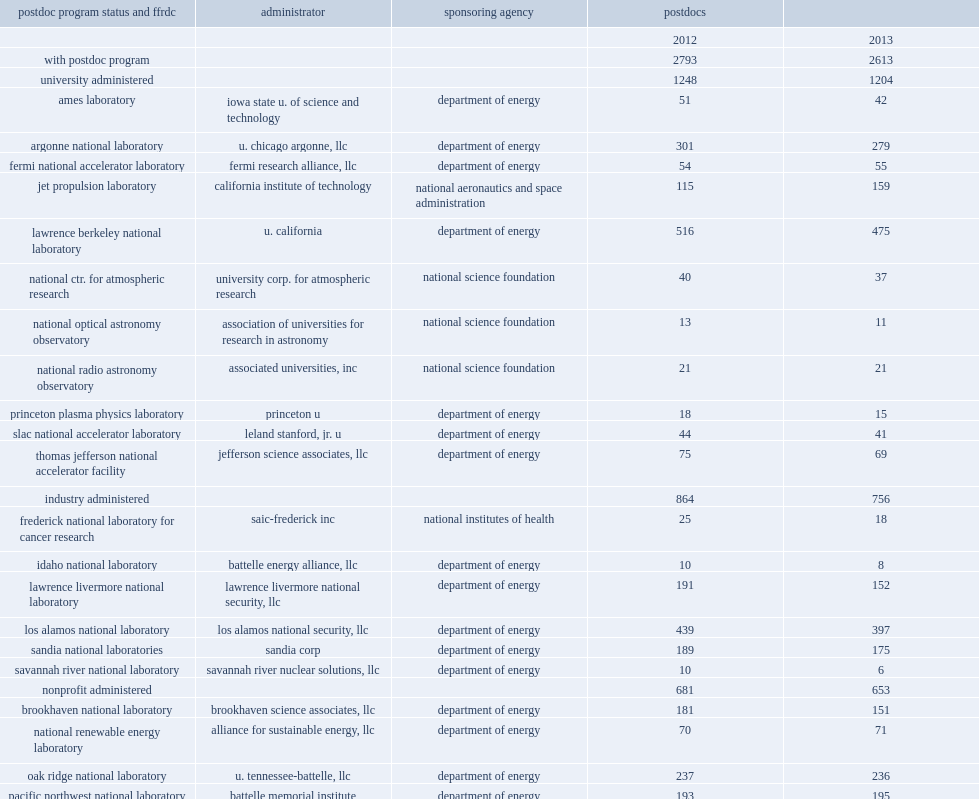How many postdocs did ffrdcs employ in 2013? 2613.0. These ffrdcs employed 2,613 postdocs, how many percent of decrease from fall 2012? 0.064447. 